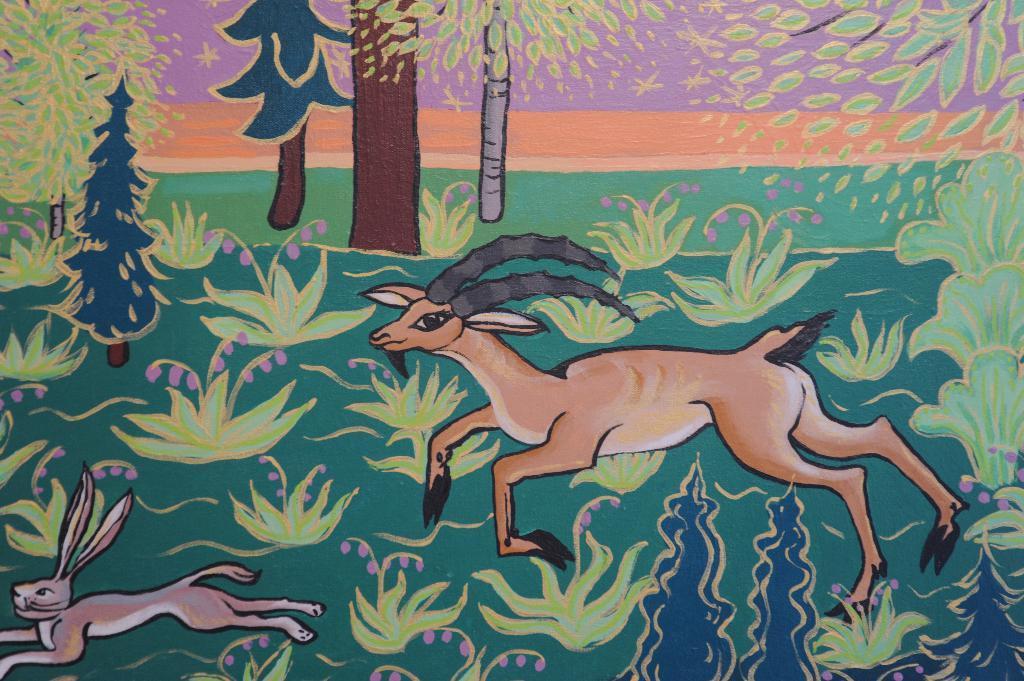Describe this image in one or two sentences. In this image there is a painting of rabbit and deer running on the grass, beside that there are trees. 